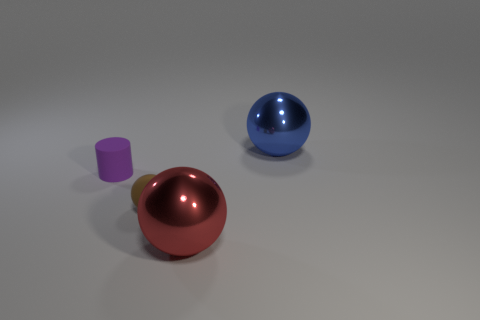Subtract all small rubber spheres. How many spheres are left? 2 Subtract all green balls. Subtract all yellow cylinders. How many balls are left? 3 Add 1 brown matte spheres. How many objects exist? 5 Subtract all spheres. How many objects are left? 1 Subtract 0 yellow balls. How many objects are left? 4 Subtract all cyan shiny spheres. Subtract all blue metallic balls. How many objects are left? 3 Add 4 small purple matte things. How many small purple matte things are left? 5 Add 4 big metallic things. How many big metallic things exist? 6 